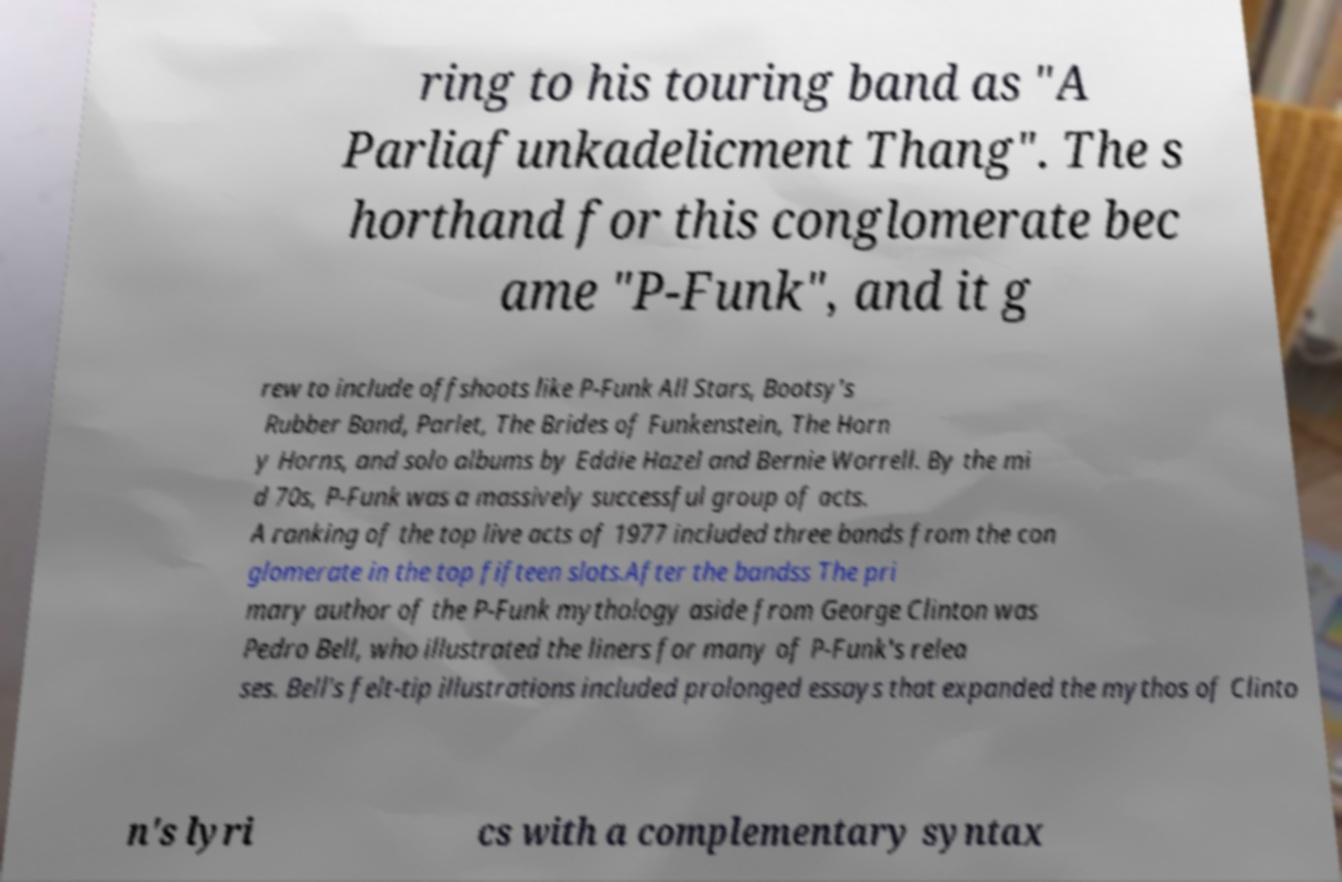Can you accurately transcribe the text from the provided image for me? ring to his touring band as "A Parliafunkadelicment Thang". The s horthand for this conglomerate bec ame "P-Funk", and it g rew to include offshoots like P-Funk All Stars, Bootsy's Rubber Band, Parlet, The Brides of Funkenstein, The Horn y Horns, and solo albums by Eddie Hazel and Bernie Worrell. By the mi d 70s, P-Funk was a massively successful group of acts. A ranking of the top live acts of 1977 included three bands from the con glomerate in the top fifteen slots.After the bandss The pri mary author of the P-Funk mythology aside from George Clinton was Pedro Bell, who illustrated the liners for many of P-Funk's relea ses. Bell's felt-tip illustrations included prolonged essays that expanded the mythos of Clinto n's lyri cs with a complementary syntax 